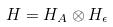<formula> <loc_0><loc_0><loc_500><loc_500>H = H _ { A } \otimes H _ { \epsilon }</formula> 